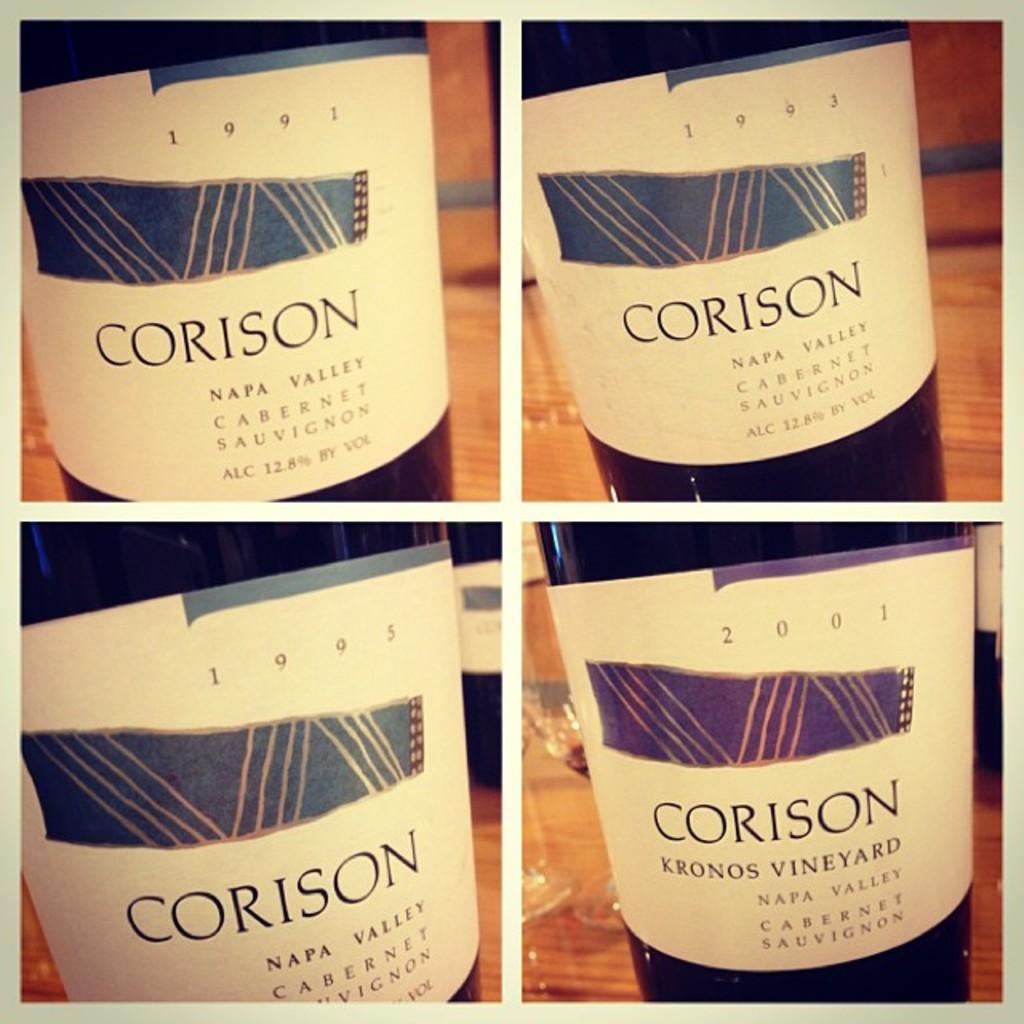<image>
Describe the image concisely. The Corison brand of wine is made in Napa Valley. 